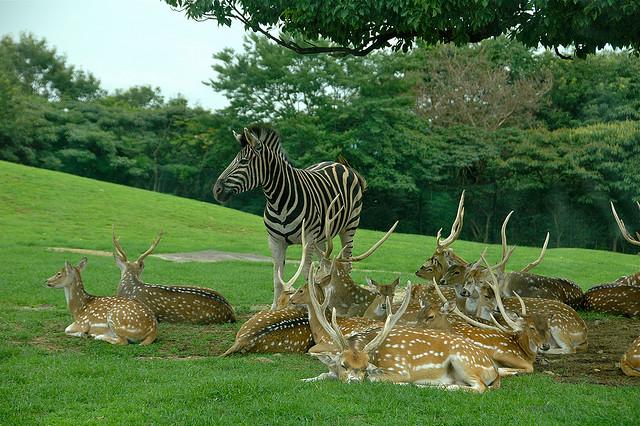What kind of animals are laying down?
Keep it brief. Deer. What country are the animals in?
Answer briefly. Africa. Do you see a lion?
Be succinct. No. 